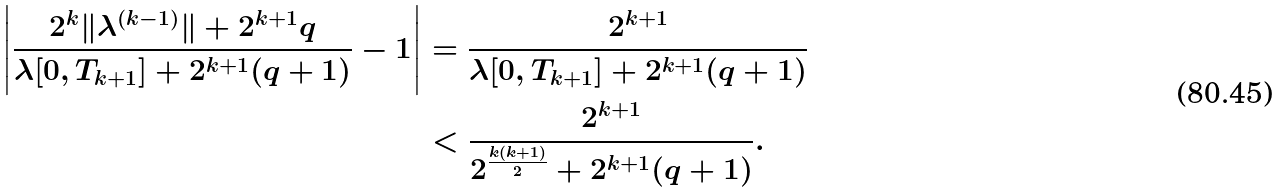Convert formula to latex. <formula><loc_0><loc_0><loc_500><loc_500>\left | \frac { 2 ^ { k } \| \lambda ^ { ( k - 1 ) } \| + 2 ^ { k + 1 } q } { \lambda [ 0 , T _ { k + 1 } ] + 2 ^ { k + 1 } ( q + 1 ) } - 1 \right | & = \frac { 2 ^ { k + 1 } } { \lambda [ 0 , T _ { k + 1 } ] + 2 ^ { k + 1 } ( q + 1 ) } \\ & < \frac { 2 ^ { k + 1 } } { 2 ^ { \frac { k ( k + 1 ) } { 2 } } + 2 ^ { k + 1 } ( q + 1 ) } .</formula> 